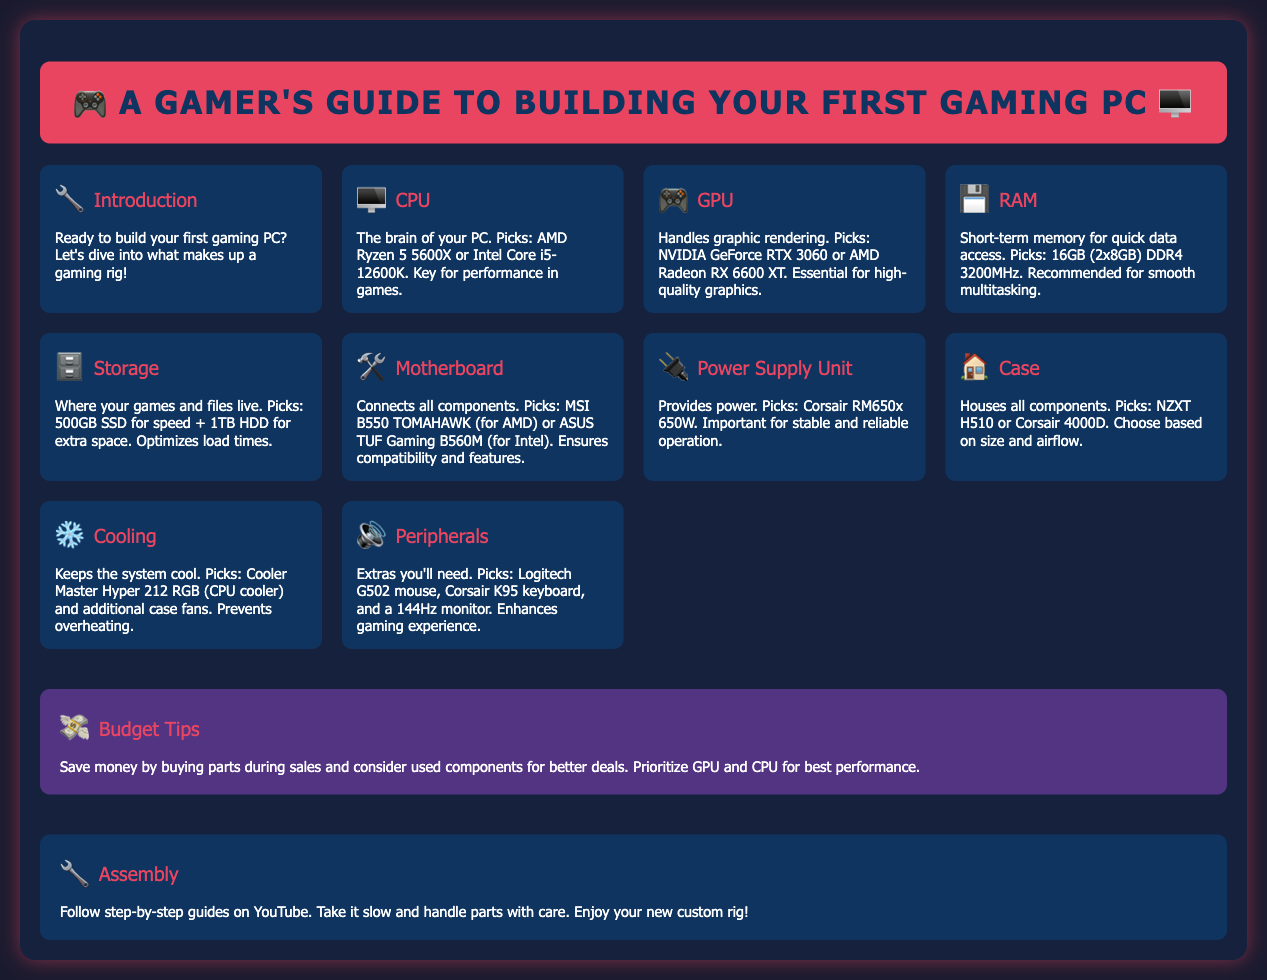What is the CPU recommendation? The CPU recommendation is found in the "CPU" section of the document, which states AMD Ryzen 5 5600X or Intel Core i5-12600K.
Answer: AMD Ryzen 5 5600X or Intel Core i5-12600K What does RAM stand for? In the document, RAM stands for short-term memory and is mentioned in the "RAM" section.
Answer: Random Access Memory Which GPU is recommended for gaming? The GPU recommendation is found in the "GPU" section where it states NVIDIA GeForce RTX 3060 or AMD Radeon RX 6600 XT.
Answer: NVIDIA GeForce RTX 3060 or AMD Radeon RX 6600 XT How much RAM is suggested? The "RAM" section specifies the amount of RAM recommended for smooth multitasking is 16GB (2x8GB).
Answer: 16GB (2x8GB) What is the power supply unit recommendation? The recommendation for the power supply unit is stated in the "Power Supply Unit" section as Corsair RM650x 650W.
Answer: Corsair RM650x 650W What is a key tip for saving money? In the "Budget Tips" section, it states to save money by buying parts during sales.
Answer: Buy parts during sales How many GPUs options are included? The document lists two GPU options in the "GPU" section, thus counting them provides the answer.
Answer: Two What is mentioned in the assembly section? The assembly section advises to follow step-by-step guides on YouTube and to take it slow.
Answer: Follow step-by-step guides on YouTube What type of cooling is recommended? The "Cooling" section suggests Cooler Master Hyper 212 RGB for CPU cooling.
Answer: Cooler Master Hyper 212 RGB 